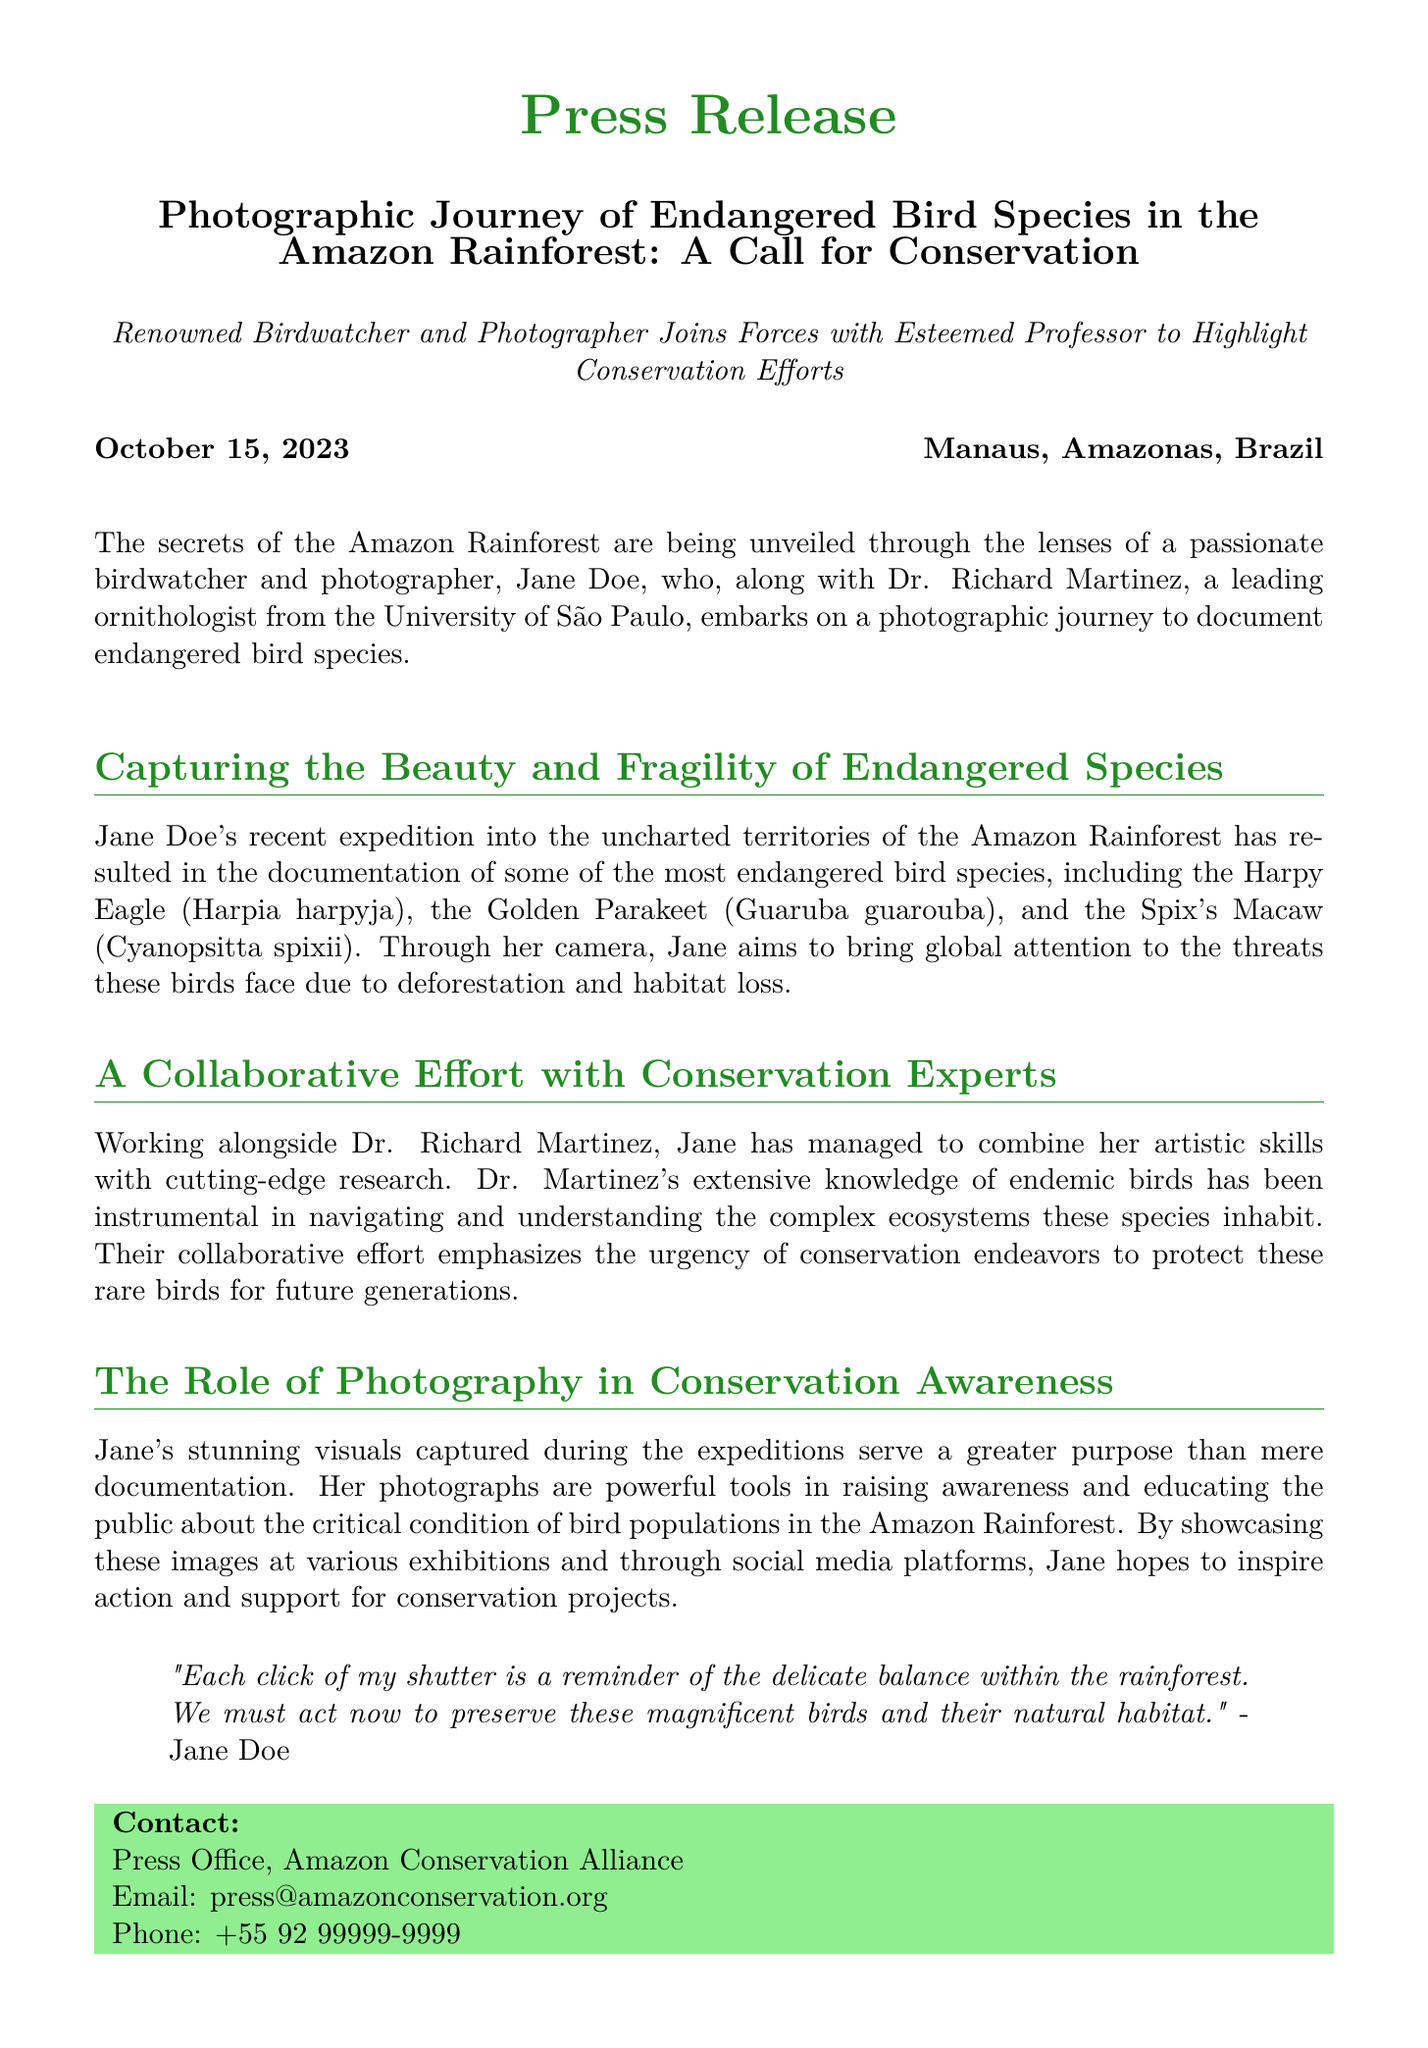What is the name of the photographer? The document mentions Jane Doe as the renowned birdwatcher and photographer.
Answer: Jane Doe Who is the leading ornithologist mentioned? The press release states that Dr. Richard Martinez is the leading ornithologist from the University of São Paulo.
Answer: Dr. Richard Martinez What species did Jane Doe document? The document lists endangered bird species, including the Harpy Eagle, the Golden Parakeet, and Spix's Macaw.
Answer: Harpy Eagle, Golden Parakeet, Spix's Macaw When was the press release issued? The specific date of the press release is indicated at the beginning as October 15, 2023.
Answer: October 15, 2023 What is the name of the organization connected to the press office? The document mentions the Amazon Conservation Alliance as the organization connected to the press office.
Answer: Amazon Conservation Alliance What does Jane aim to raise awareness about? According to the document, Jane aims to raise awareness about the threats endangered birds face due to deforestation and habitat loss.
Answer: Deforestation and habitat loss What is the purpose of Jane's photographs? The press release states that her photographs serve as powerful tools for raising awareness and educating the public.
Answer: Raising awareness and educating the public Where is the location mentioned in the press release? The document indicates that the location of the press release is Manaus, Amazonas, Brazil.
Answer: Manaus, Amazonas, Brazil What does Jane emphasize in her statement? Jane emphasizes the delicate balance within the rainforest and the need for immediate action.
Answer: The delicate balance within the rainforest and the need for immediate action 